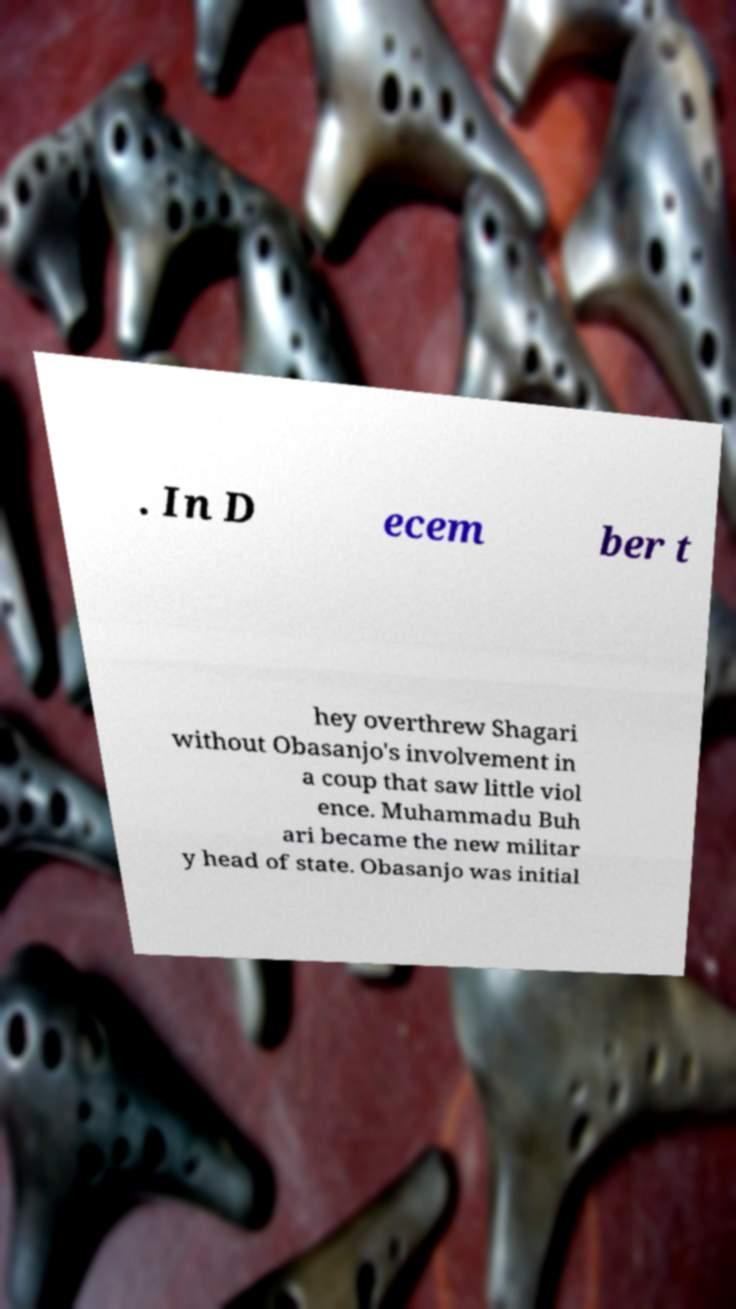There's text embedded in this image that I need extracted. Can you transcribe it verbatim? . In D ecem ber t hey overthrew Shagari without Obasanjo's involvement in a coup that saw little viol ence. Muhammadu Buh ari became the new militar y head of state. Obasanjo was initial 